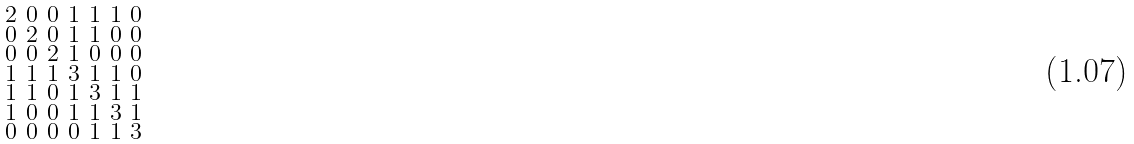Convert formula to latex. <formula><loc_0><loc_0><loc_500><loc_500>\begin{smallmatrix} 2 & 0 & 0 & 1 & 1 & 1 & 0 \\ 0 & 2 & 0 & 1 & 1 & 0 & 0 \\ 0 & 0 & 2 & 1 & 0 & 0 & 0 \\ 1 & 1 & 1 & 3 & 1 & 1 & 0 \\ 1 & 1 & 0 & 1 & 3 & 1 & 1 \\ 1 & 0 & 0 & 1 & 1 & 3 & 1 \\ 0 & 0 & 0 & 0 & 1 & 1 & 3 \end{smallmatrix}</formula> 